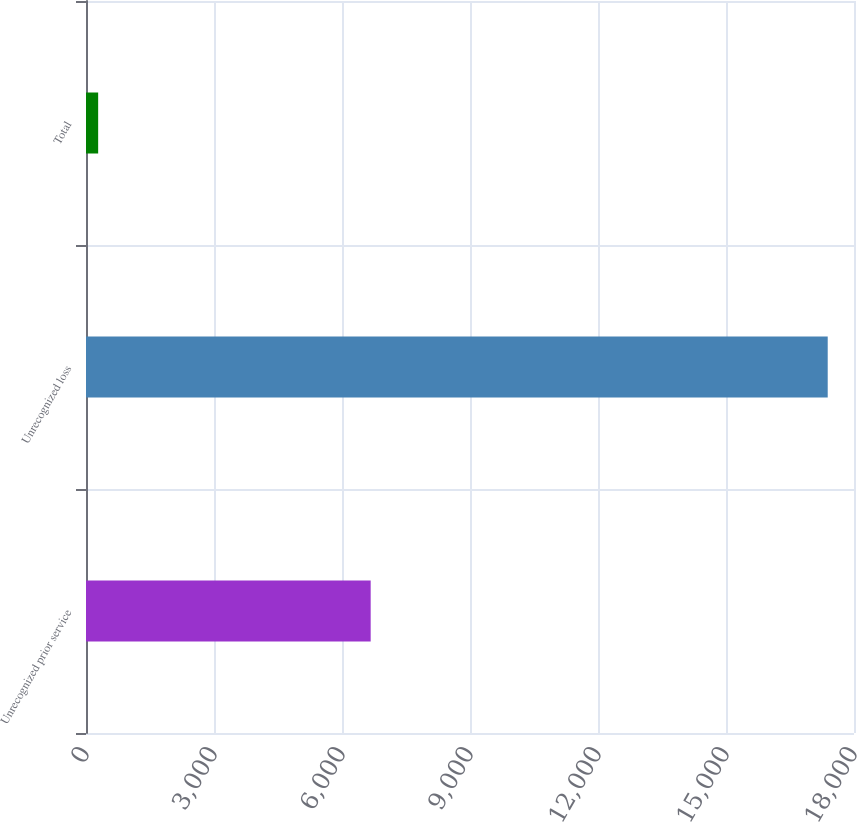Convert chart to OTSL. <chart><loc_0><loc_0><loc_500><loc_500><bar_chart><fcel>Unrecognized prior service<fcel>Unrecognized loss<fcel>Total<nl><fcel>6672<fcel>17384<fcel>285<nl></chart> 